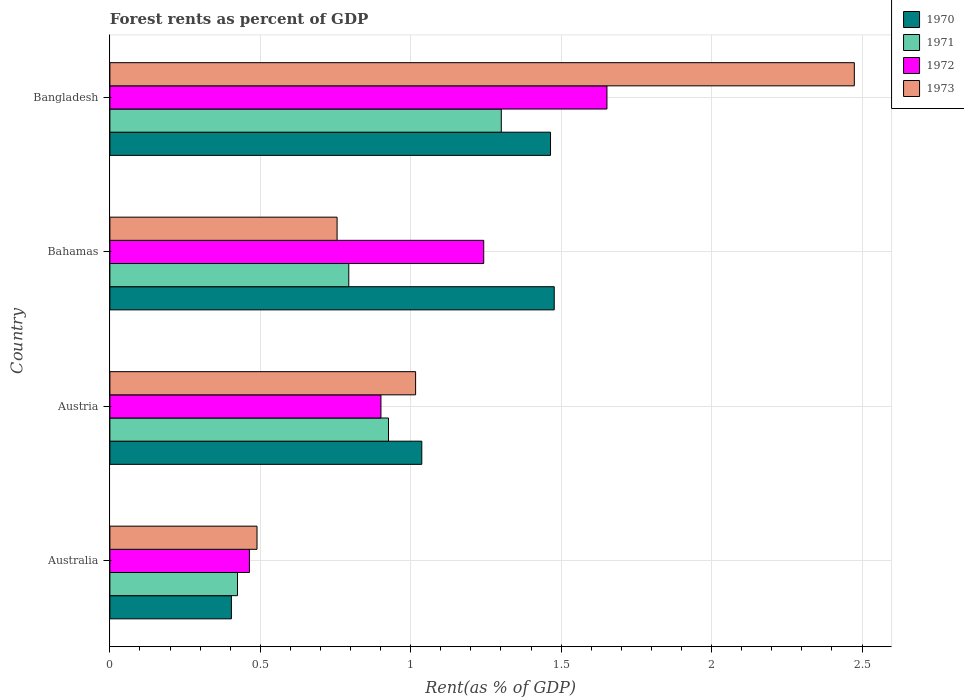How many different coloured bars are there?
Give a very brief answer. 4. How many groups of bars are there?
Make the answer very short. 4. Are the number of bars per tick equal to the number of legend labels?
Provide a short and direct response. Yes. What is the label of the 1st group of bars from the top?
Provide a succinct answer. Bangladesh. In how many cases, is the number of bars for a given country not equal to the number of legend labels?
Keep it short and to the point. 0. What is the forest rent in 1973 in Australia?
Provide a succinct answer. 0.49. Across all countries, what is the maximum forest rent in 1971?
Offer a terse response. 1.3. Across all countries, what is the minimum forest rent in 1970?
Your answer should be compact. 0.4. In which country was the forest rent in 1973 minimum?
Ensure brevity in your answer.  Australia. What is the total forest rent in 1970 in the graph?
Your answer should be very brief. 4.38. What is the difference between the forest rent in 1972 in Australia and that in Bahamas?
Offer a very short reply. -0.78. What is the difference between the forest rent in 1972 in Australia and the forest rent in 1970 in Bahamas?
Offer a terse response. -1.01. What is the average forest rent in 1973 per country?
Your answer should be very brief. 1.18. What is the difference between the forest rent in 1973 and forest rent in 1972 in Bangladesh?
Ensure brevity in your answer.  0.82. What is the ratio of the forest rent in 1972 in Australia to that in Bangladesh?
Your answer should be very brief. 0.28. Is the forest rent in 1970 in Australia less than that in Austria?
Offer a terse response. Yes. What is the difference between the highest and the second highest forest rent in 1973?
Provide a succinct answer. 1.46. What is the difference between the highest and the lowest forest rent in 1970?
Give a very brief answer. 1.07. In how many countries, is the forest rent in 1972 greater than the average forest rent in 1972 taken over all countries?
Offer a terse response. 2. Is the sum of the forest rent in 1970 in Australia and Austria greater than the maximum forest rent in 1971 across all countries?
Offer a terse response. Yes. Is it the case that in every country, the sum of the forest rent in 1973 and forest rent in 1972 is greater than the sum of forest rent in 1971 and forest rent in 1970?
Provide a short and direct response. No. What does the 4th bar from the top in Australia represents?
Your answer should be compact. 1970. What does the 2nd bar from the bottom in Bangladesh represents?
Offer a terse response. 1971. How many bars are there?
Your answer should be very brief. 16. How many countries are there in the graph?
Your answer should be very brief. 4. Are the values on the major ticks of X-axis written in scientific E-notation?
Give a very brief answer. No. Does the graph contain any zero values?
Your answer should be compact. No. Does the graph contain grids?
Your answer should be compact. Yes. How many legend labels are there?
Ensure brevity in your answer.  4. How are the legend labels stacked?
Your answer should be very brief. Vertical. What is the title of the graph?
Your response must be concise. Forest rents as percent of GDP. Does "1991" appear as one of the legend labels in the graph?
Give a very brief answer. No. What is the label or title of the X-axis?
Your answer should be compact. Rent(as % of GDP). What is the Rent(as % of GDP) in 1970 in Australia?
Provide a short and direct response. 0.4. What is the Rent(as % of GDP) in 1971 in Australia?
Give a very brief answer. 0.42. What is the Rent(as % of GDP) in 1972 in Australia?
Provide a short and direct response. 0.46. What is the Rent(as % of GDP) in 1973 in Australia?
Provide a short and direct response. 0.49. What is the Rent(as % of GDP) of 1970 in Austria?
Your answer should be compact. 1.04. What is the Rent(as % of GDP) of 1971 in Austria?
Give a very brief answer. 0.93. What is the Rent(as % of GDP) of 1972 in Austria?
Your answer should be very brief. 0.9. What is the Rent(as % of GDP) in 1973 in Austria?
Give a very brief answer. 1.02. What is the Rent(as % of GDP) in 1970 in Bahamas?
Ensure brevity in your answer.  1.48. What is the Rent(as % of GDP) of 1971 in Bahamas?
Ensure brevity in your answer.  0.79. What is the Rent(as % of GDP) of 1972 in Bahamas?
Keep it short and to the point. 1.24. What is the Rent(as % of GDP) of 1973 in Bahamas?
Ensure brevity in your answer.  0.76. What is the Rent(as % of GDP) in 1970 in Bangladesh?
Give a very brief answer. 1.46. What is the Rent(as % of GDP) of 1971 in Bangladesh?
Your answer should be compact. 1.3. What is the Rent(as % of GDP) of 1972 in Bangladesh?
Your answer should be compact. 1.65. What is the Rent(as % of GDP) of 1973 in Bangladesh?
Provide a short and direct response. 2.47. Across all countries, what is the maximum Rent(as % of GDP) of 1970?
Your answer should be very brief. 1.48. Across all countries, what is the maximum Rent(as % of GDP) of 1971?
Keep it short and to the point. 1.3. Across all countries, what is the maximum Rent(as % of GDP) of 1972?
Provide a short and direct response. 1.65. Across all countries, what is the maximum Rent(as % of GDP) in 1973?
Your answer should be very brief. 2.47. Across all countries, what is the minimum Rent(as % of GDP) of 1970?
Your answer should be compact. 0.4. Across all countries, what is the minimum Rent(as % of GDP) of 1971?
Your answer should be very brief. 0.42. Across all countries, what is the minimum Rent(as % of GDP) in 1972?
Make the answer very short. 0.46. Across all countries, what is the minimum Rent(as % of GDP) in 1973?
Provide a succinct answer. 0.49. What is the total Rent(as % of GDP) of 1970 in the graph?
Ensure brevity in your answer.  4.38. What is the total Rent(as % of GDP) in 1971 in the graph?
Provide a short and direct response. 3.45. What is the total Rent(as % of GDP) in 1972 in the graph?
Give a very brief answer. 4.26. What is the total Rent(as % of GDP) of 1973 in the graph?
Provide a succinct answer. 4.74. What is the difference between the Rent(as % of GDP) of 1970 in Australia and that in Austria?
Give a very brief answer. -0.63. What is the difference between the Rent(as % of GDP) in 1971 in Australia and that in Austria?
Offer a terse response. -0.5. What is the difference between the Rent(as % of GDP) of 1972 in Australia and that in Austria?
Provide a short and direct response. -0.44. What is the difference between the Rent(as % of GDP) of 1973 in Australia and that in Austria?
Your response must be concise. -0.53. What is the difference between the Rent(as % of GDP) in 1970 in Australia and that in Bahamas?
Provide a short and direct response. -1.07. What is the difference between the Rent(as % of GDP) of 1971 in Australia and that in Bahamas?
Your response must be concise. -0.37. What is the difference between the Rent(as % of GDP) of 1972 in Australia and that in Bahamas?
Ensure brevity in your answer.  -0.78. What is the difference between the Rent(as % of GDP) of 1973 in Australia and that in Bahamas?
Give a very brief answer. -0.27. What is the difference between the Rent(as % of GDP) in 1970 in Australia and that in Bangladesh?
Offer a terse response. -1.06. What is the difference between the Rent(as % of GDP) in 1971 in Australia and that in Bangladesh?
Keep it short and to the point. -0.88. What is the difference between the Rent(as % of GDP) of 1972 in Australia and that in Bangladesh?
Your response must be concise. -1.19. What is the difference between the Rent(as % of GDP) of 1973 in Australia and that in Bangladesh?
Provide a short and direct response. -1.99. What is the difference between the Rent(as % of GDP) in 1970 in Austria and that in Bahamas?
Offer a very short reply. -0.44. What is the difference between the Rent(as % of GDP) in 1971 in Austria and that in Bahamas?
Your answer should be compact. 0.13. What is the difference between the Rent(as % of GDP) of 1972 in Austria and that in Bahamas?
Give a very brief answer. -0.34. What is the difference between the Rent(as % of GDP) in 1973 in Austria and that in Bahamas?
Keep it short and to the point. 0.26. What is the difference between the Rent(as % of GDP) of 1970 in Austria and that in Bangladesh?
Keep it short and to the point. -0.43. What is the difference between the Rent(as % of GDP) of 1971 in Austria and that in Bangladesh?
Offer a very short reply. -0.38. What is the difference between the Rent(as % of GDP) in 1972 in Austria and that in Bangladesh?
Your response must be concise. -0.75. What is the difference between the Rent(as % of GDP) in 1973 in Austria and that in Bangladesh?
Your answer should be compact. -1.46. What is the difference between the Rent(as % of GDP) of 1970 in Bahamas and that in Bangladesh?
Offer a terse response. 0.01. What is the difference between the Rent(as % of GDP) of 1971 in Bahamas and that in Bangladesh?
Offer a very short reply. -0.51. What is the difference between the Rent(as % of GDP) in 1972 in Bahamas and that in Bangladesh?
Your answer should be very brief. -0.41. What is the difference between the Rent(as % of GDP) of 1973 in Bahamas and that in Bangladesh?
Your response must be concise. -1.72. What is the difference between the Rent(as % of GDP) in 1970 in Australia and the Rent(as % of GDP) in 1971 in Austria?
Keep it short and to the point. -0.52. What is the difference between the Rent(as % of GDP) of 1970 in Australia and the Rent(as % of GDP) of 1972 in Austria?
Give a very brief answer. -0.5. What is the difference between the Rent(as % of GDP) in 1970 in Australia and the Rent(as % of GDP) in 1973 in Austria?
Make the answer very short. -0.61. What is the difference between the Rent(as % of GDP) in 1971 in Australia and the Rent(as % of GDP) in 1972 in Austria?
Your response must be concise. -0.48. What is the difference between the Rent(as % of GDP) of 1971 in Australia and the Rent(as % of GDP) of 1973 in Austria?
Provide a succinct answer. -0.59. What is the difference between the Rent(as % of GDP) of 1972 in Australia and the Rent(as % of GDP) of 1973 in Austria?
Offer a very short reply. -0.55. What is the difference between the Rent(as % of GDP) of 1970 in Australia and the Rent(as % of GDP) of 1971 in Bahamas?
Make the answer very short. -0.39. What is the difference between the Rent(as % of GDP) in 1970 in Australia and the Rent(as % of GDP) in 1972 in Bahamas?
Offer a terse response. -0.84. What is the difference between the Rent(as % of GDP) in 1970 in Australia and the Rent(as % of GDP) in 1973 in Bahamas?
Your answer should be compact. -0.35. What is the difference between the Rent(as % of GDP) in 1971 in Australia and the Rent(as % of GDP) in 1972 in Bahamas?
Provide a succinct answer. -0.82. What is the difference between the Rent(as % of GDP) in 1971 in Australia and the Rent(as % of GDP) in 1973 in Bahamas?
Offer a terse response. -0.33. What is the difference between the Rent(as % of GDP) in 1972 in Australia and the Rent(as % of GDP) in 1973 in Bahamas?
Ensure brevity in your answer.  -0.29. What is the difference between the Rent(as % of GDP) in 1970 in Australia and the Rent(as % of GDP) in 1971 in Bangladesh?
Your answer should be compact. -0.9. What is the difference between the Rent(as % of GDP) in 1970 in Australia and the Rent(as % of GDP) in 1972 in Bangladesh?
Your answer should be very brief. -1.25. What is the difference between the Rent(as % of GDP) in 1970 in Australia and the Rent(as % of GDP) in 1973 in Bangladesh?
Offer a very short reply. -2.07. What is the difference between the Rent(as % of GDP) in 1971 in Australia and the Rent(as % of GDP) in 1972 in Bangladesh?
Keep it short and to the point. -1.23. What is the difference between the Rent(as % of GDP) of 1971 in Australia and the Rent(as % of GDP) of 1973 in Bangladesh?
Your answer should be very brief. -2.05. What is the difference between the Rent(as % of GDP) in 1972 in Australia and the Rent(as % of GDP) in 1973 in Bangladesh?
Give a very brief answer. -2.01. What is the difference between the Rent(as % of GDP) of 1970 in Austria and the Rent(as % of GDP) of 1971 in Bahamas?
Your answer should be compact. 0.24. What is the difference between the Rent(as % of GDP) of 1970 in Austria and the Rent(as % of GDP) of 1972 in Bahamas?
Make the answer very short. -0.21. What is the difference between the Rent(as % of GDP) of 1970 in Austria and the Rent(as % of GDP) of 1973 in Bahamas?
Keep it short and to the point. 0.28. What is the difference between the Rent(as % of GDP) of 1971 in Austria and the Rent(as % of GDP) of 1972 in Bahamas?
Ensure brevity in your answer.  -0.32. What is the difference between the Rent(as % of GDP) in 1971 in Austria and the Rent(as % of GDP) in 1973 in Bahamas?
Make the answer very short. 0.17. What is the difference between the Rent(as % of GDP) of 1972 in Austria and the Rent(as % of GDP) of 1973 in Bahamas?
Keep it short and to the point. 0.15. What is the difference between the Rent(as % of GDP) of 1970 in Austria and the Rent(as % of GDP) of 1971 in Bangladesh?
Offer a terse response. -0.26. What is the difference between the Rent(as % of GDP) of 1970 in Austria and the Rent(as % of GDP) of 1972 in Bangladesh?
Your answer should be compact. -0.62. What is the difference between the Rent(as % of GDP) of 1970 in Austria and the Rent(as % of GDP) of 1973 in Bangladesh?
Your answer should be compact. -1.44. What is the difference between the Rent(as % of GDP) in 1971 in Austria and the Rent(as % of GDP) in 1972 in Bangladesh?
Keep it short and to the point. -0.73. What is the difference between the Rent(as % of GDP) of 1971 in Austria and the Rent(as % of GDP) of 1973 in Bangladesh?
Provide a short and direct response. -1.55. What is the difference between the Rent(as % of GDP) of 1972 in Austria and the Rent(as % of GDP) of 1973 in Bangladesh?
Your answer should be very brief. -1.57. What is the difference between the Rent(as % of GDP) of 1970 in Bahamas and the Rent(as % of GDP) of 1971 in Bangladesh?
Your answer should be very brief. 0.18. What is the difference between the Rent(as % of GDP) of 1970 in Bahamas and the Rent(as % of GDP) of 1972 in Bangladesh?
Provide a succinct answer. -0.18. What is the difference between the Rent(as % of GDP) of 1970 in Bahamas and the Rent(as % of GDP) of 1973 in Bangladesh?
Your answer should be compact. -1. What is the difference between the Rent(as % of GDP) in 1971 in Bahamas and the Rent(as % of GDP) in 1972 in Bangladesh?
Your answer should be very brief. -0.86. What is the difference between the Rent(as % of GDP) of 1971 in Bahamas and the Rent(as % of GDP) of 1973 in Bangladesh?
Your response must be concise. -1.68. What is the difference between the Rent(as % of GDP) of 1972 in Bahamas and the Rent(as % of GDP) of 1973 in Bangladesh?
Provide a short and direct response. -1.23. What is the average Rent(as % of GDP) in 1970 per country?
Keep it short and to the point. 1.1. What is the average Rent(as % of GDP) in 1971 per country?
Ensure brevity in your answer.  0.86. What is the average Rent(as % of GDP) of 1972 per country?
Give a very brief answer. 1.06. What is the average Rent(as % of GDP) in 1973 per country?
Give a very brief answer. 1.18. What is the difference between the Rent(as % of GDP) in 1970 and Rent(as % of GDP) in 1971 in Australia?
Your answer should be very brief. -0.02. What is the difference between the Rent(as % of GDP) of 1970 and Rent(as % of GDP) of 1972 in Australia?
Provide a succinct answer. -0.06. What is the difference between the Rent(as % of GDP) of 1970 and Rent(as % of GDP) of 1973 in Australia?
Make the answer very short. -0.09. What is the difference between the Rent(as % of GDP) of 1971 and Rent(as % of GDP) of 1972 in Australia?
Offer a terse response. -0.04. What is the difference between the Rent(as % of GDP) of 1971 and Rent(as % of GDP) of 1973 in Australia?
Offer a very short reply. -0.06. What is the difference between the Rent(as % of GDP) in 1972 and Rent(as % of GDP) in 1973 in Australia?
Provide a succinct answer. -0.03. What is the difference between the Rent(as % of GDP) in 1970 and Rent(as % of GDP) in 1971 in Austria?
Provide a succinct answer. 0.11. What is the difference between the Rent(as % of GDP) in 1970 and Rent(as % of GDP) in 1972 in Austria?
Provide a short and direct response. 0.14. What is the difference between the Rent(as % of GDP) in 1970 and Rent(as % of GDP) in 1973 in Austria?
Your answer should be compact. 0.02. What is the difference between the Rent(as % of GDP) of 1971 and Rent(as % of GDP) of 1972 in Austria?
Offer a terse response. 0.03. What is the difference between the Rent(as % of GDP) in 1971 and Rent(as % of GDP) in 1973 in Austria?
Give a very brief answer. -0.09. What is the difference between the Rent(as % of GDP) in 1972 and Rent(as % of GDP) in 1973 in Austria?
Make the answer very short. -0.12. What is the difference between the Rent(as % of GDP) in 1970 and Rent(as % of GDP) in 1971 in Bahamas?
Ensure brevity in your answer.  0.68. What is the difference between the Rent(as % of GDP) of 1970 and Rent(as % of GDP) of 1972 in Bahamas?
Ensure brevity in your answer.  0.23. What is the difference between the Rent(as % of GDP) of 1970 and Rent(as % of GDP) of 1973 in Bahamas?
Offer a very short reply. 0.72. What is the difference between the Rent(as % of GDP) in 1971 and Rent(as % of GDP) in 1972 in Bahamas?
Offer a very short reply. -0.45. What is the difference between the Rent(as % of GDP) in 1971 and Rent(as % of GDP) in 1973 in Bahamas?
Ensure brevity in your answer.  0.04. What is the difference between the Rent(as % of GDP) in 1972 and Rent(as % of GDP) in 1973 in Bahamas?
Make the answer very short. 0.49. What is the difference between the Rent(as % of GDP) in 1970 and Rent(as % of GDP) in 1971 in Bangladesh?
Keep it short and to the point. 0.16. What is the difference between the Rent(as % of GDP) of 1970 and Rent(as % of GDP) of 1972 in Bangladesh?
Your answer should be very brief. -0.19. What is the difference between the Rent(as % of GDP) in 1970 and Rent(as % of GDP) in 1973 in Bangladesh?
Provide a short and direct response. -1.01. What is the difference between the Rent(as % of GDP) in 1971 and Rent(as % of GDP) in 1972 in Bangladesh?
Your response must be concise. -0.35. What is the difference between the Rent(as % of GDP) of 1971 and Rent(as % of GDP) of 1973 in Bangladesh?
Provide a short and direct response. -1.17. What is the difference between the Rent(as % of GDP) of 1972 and Rent(as % of GDP) of 1973 in Bangladesh?
Make the answer very short. -0.82. What is the ratio of the Rent(as % of GDP) of 1970 in Australia to that in Austria?
Make the answer very short. 0.39. What is the ratio of the Rent(as % of GDP) in 1971 in Australia to that in Austria?
Ensure brevity in your answer.  0.46. What is the ratio of the Rent(as % of GDP) in 1972 in Australia to that in Austria?
Your answer should be compact. 0.51. What is the ratio of the Rent(as % of GDP) of 1973 in Australia to that in Austria?
Make the answer very short. 0.48. What is the ratio of the Rent(as % of GDP) of 1970 in Australia to that in Bahamas?
Provide a succinct answer. 0.27. What is the ratio of the Rent(as % of GDP) in 1971 in Australia to that in Bahamas?
Your answer should be compact. 0.53. What is the ratio of the Rent(as % of GDP) of 1972 in Australia to that in Bahamas?
Offer a terse response. 0.37. What is the ratio of the Rent(as % of GDP) in 1973 in Australia to that in Bahamas?
Offer a very short reply. 0.65. What is the ratio of the Rent(as % of GDP) of 1970 in Australia to that in Bangladesh?
Offer a terse response. 0.28. What is the ratio of the Rent(as % of GDP) in 1971 in Australia to that in Bangladesh?
Your answer should be very brief. 0.33. What is the ratio of the Rent(as % of GDP) of 1972 in Australia to that in Bangladesh?
Your answer should be very brief. 0.28. What is the ratio of the Rent(as % of GDP) in 1973 in Australia to that in Bangladesh?
Your answer should be very brief. 0.2. What is the ratio of the Rent(as % of GDP) in 1970 in Austria to that in Bahamas?
Offer a very short reply. 0.7. What is the ratio of the Rent(as % of GDP) of 1971 in Austria to that in Bahamas?
Your response must be concise. 1.17. What is the ratio of the Rent(as % of GDP) of 1972 in Austria to that in Bahamas?
Give a very brief answer. 0.72. What is the ratio of the Rent(as % of GDP) in 1973 in Austria to that in Bahamas?
Provide a short and direct response. 1.35. What is the ratio of the Rent(as % of GDP) in 1970 in Austria to that in Bangladesh?
Make the answer very short. 0.71. What is the ratio of the Rent(as % of GDP) of 1971 in Austria to that in Bangladesh?
Your answer should be very brief. 0.71. What is the ratio of the Rent(as % of GDP) of 1972 in Austria to that in Bangladesh?
Ensure brevity in your answer.  0.55. What is the ratio of the Rent(as % of GDP) of 1973 in Austria to that in Bangladesh?
Provide a short and direct response. 0.41. What is the ratio of the Rent(as % of GDP) of 1970 in Bahamas to that in Bangladesh?
Your answer should be very brief. 1.01. What is the ratio of the Rent(as % of GDP) of 1971 in Bahamas to that in Bangladesh?
Ensure brevity in your answer.  0.61. What is the ratio of the Rent(as % of GDP) of 1972 in Bahamas to that in Bangladesh?
Ensure brevity in your answer.  0.75. What is the ratio of the Rent(as % of GDP) of 1973 in Bahamas to that in Bangladesh?
Ensure brevity in your answer.  0.31. What is the difference between the highest and the second highest Rent(as % of GDP) in 1970?
Provide a short and direct response. 0.01. What is the difference between the highest and the second highest Rent(as % of GDP) of 1971?
Your response must be concise. 0.38. What is the difference between the highest and the second highest Rent(as % of GDP) of 1972?
Keep it short and to the point. 0.41. What is the difference between the highest and the second highest Rent(as % of GDP) in 1973?
Provide a short and direct response. 1.46. What is the difference between the highest and the lowest Rent(as % of GDP) of 1970?
Provide a succinct answer. 1.07. What is the difference between the highest and the lowest Rent(as % of GDP) in 1971?
Your answer should be compact. 0.88. What is the difference between the highest and the lowest Rent(as % of GDP) in 1972?
Your answer should be very brief. 1.19. What is the difference between the highest and the lowest Rent(as % of GDP) of 1973?
Provide a succinct answer. 1.99. 